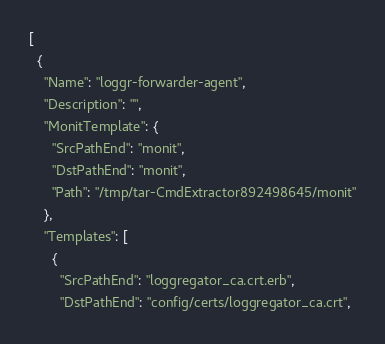<code> <loc_0><loc_0><loc_500><loc_500><_YAML_>[
  {
    "Name": "loggr-forwarder-agent",
    "Description": "",
    "MonitTemplate": {
      "SrcPathEnd": "monit",
      "DstPathEnd": "monit",
      "Path": "/tmp/tar-CmdExtractor892498645/monit"
    },
    "Templates": [
      {
        "SrcPathEnd": "loggregator_ca.crt.erb",
        "DstPathEnd": "config/certs/loggregator_ca.crt",</code> 